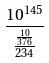<formula> <loc_0><loc_0><loc_500><loc_500>\frac { 1 0 ^ { 1 4 5 } } { \frac { \frac { 1 0 } { 3 7 6 } } { 2 3 4 } }</formula> 